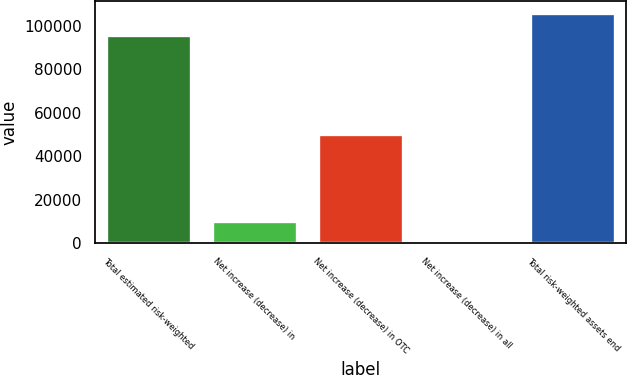Convert chart to OTSL. <chart><loc_0><loc_0><loc_500><loc_500><bar_chart><fcel>Total estimated risk-weighted<fcel>Net increase (decrease) in<fcel>Net increase (decrease) in OTC<fcel>Net increase (decrease) in all<fcel>Total risk-weighted assets end<nl><fcel>95893<fcel>10193.7<fcel>50052.5<fcel>229<fcel>105858<nl></chart> 